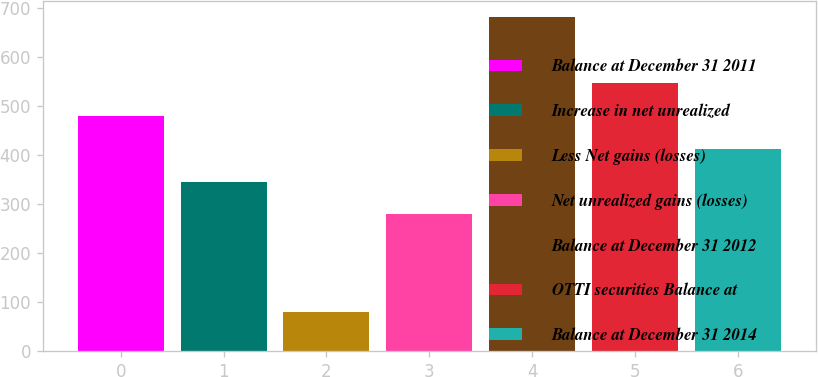Convert chart to OTSL. <chart><loc_0><loc_0><loc_500><loc_500><bar_chart><fcel>Balance at December 31 2011<fcel>Increase in net unrealized<fcel>Less Net gains (losses)<fcel>Net unrealized gains (losses)<fcel>Balance at December 31 2012<fcel>OTTI securities Balance at<fcel>Balance at December 31 2014<nl><fcel>479.4<fcel>345.8<fcel>79.8<fcel>279<fcel>681<fcel>546.2<fcel>412.6<nl></chart> 